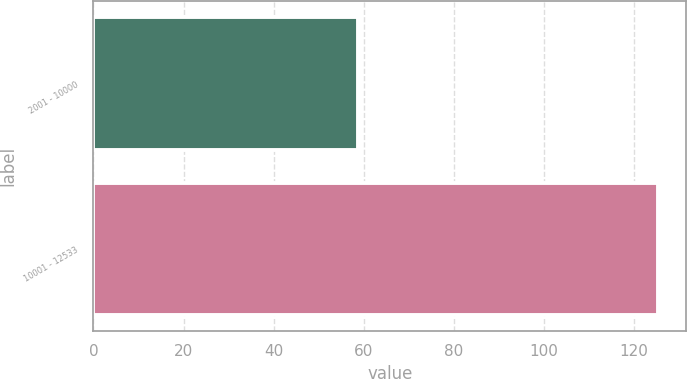Convert chart. <chart><loc_0><loc_0><loc_500><loc_500><bar_chart><fcel>2001 - 10000<fcel>10001 - 12533<nl><fcel>58.79<fcel>125.33<nl></chart> 